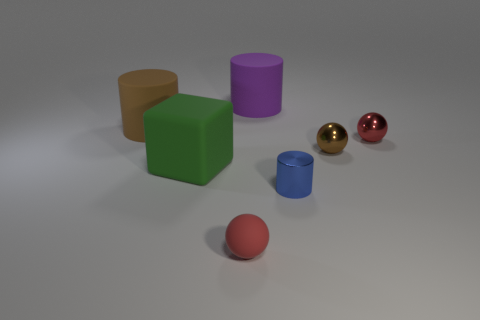Add 2 large brown matte spheres. How many objects exist? 9 Subtract all cylinders. How many objects are left? 4 Add 5 big cubes. How many big cubes are left? 6 Add 4 large gray shiny spheres. How many large gray shiny spheres exist? 4 Subtract 1 purple cylinders. How many objects are left? 6 Subtract all large blue rubber cubes. Subtract all red metal objects. How many objects are left? 6 